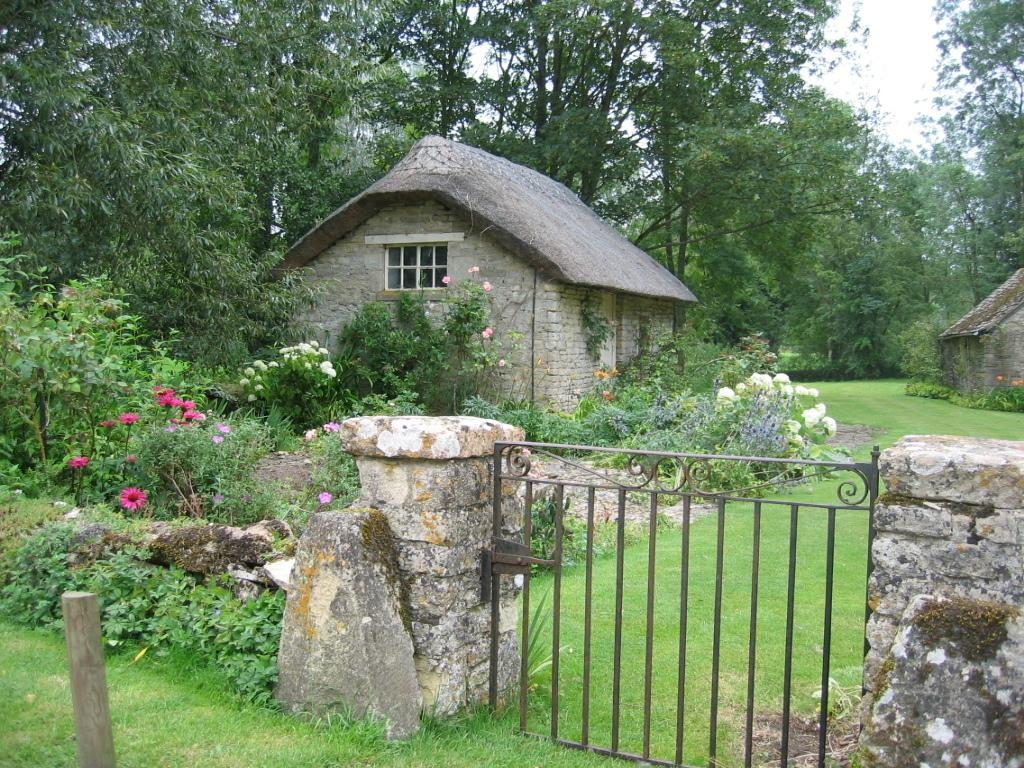What structures are located at the bottom of the image? There is a gate and a wall at the bottom of the image. What type of vegetation can be seen in the background of the image? There are plants with flowers, grass, and trees in the background of the image. How many houses are visible in the background of the image? There are two houses in the background of the image. What can be seen through the window in the background of the image? The window is in the background of the image, so it is not possible to see through it from the perspective of the image. What is visible in the sky in the background of the image? The sky is visible in the background of the image. What type of hat is the goose wearing in the image? There is no goose or hat present in the image. 